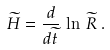<formula> <loc_0><loc_0><loc_500><loc_500>\widetilde { H } = \frac { d } { d \widetilde { t } } \, \ln \, \widetilde { R } \, .</formula> 